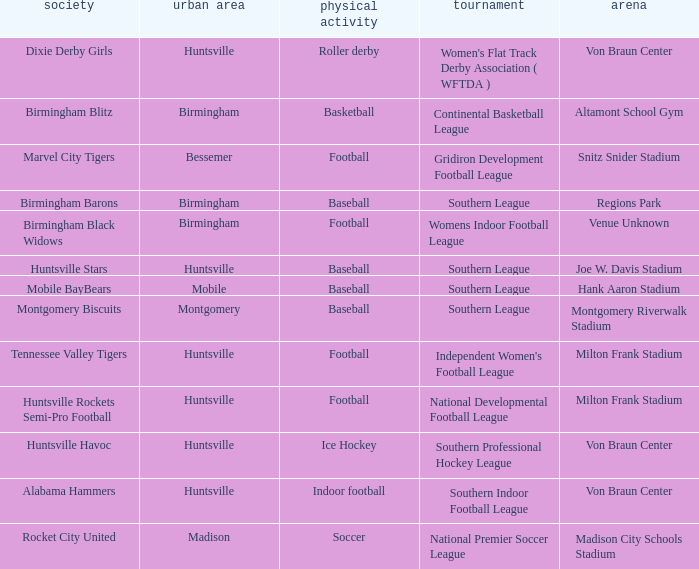Which venue held a basketball team? Altamont School Gym. 